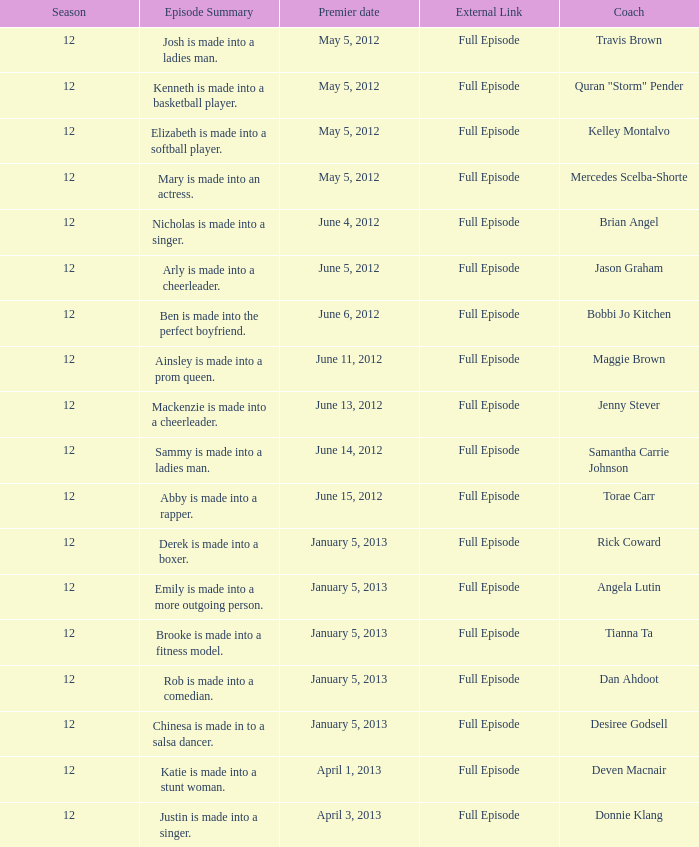Name the coach for  emily is made into a more outgoing person. Angela Lutin. 